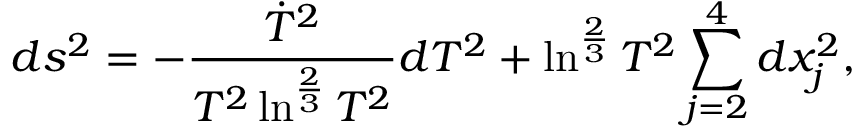Convert formula to latex. <formula><loc_0><loc_0><loc_500><loc_500>d s ^ { 2 } = - \frac { \dot { T } ^ { 2 } } { T ^ { 2 } \ln ^ { \frac { 2 } { 3 } } T ^ { 2 } } d T ^ { 2 } + \ln ^ { \frac { 2 } { 3 } } T ^ { 2 } \sum _ { j = 2 } ^ { 4 } d x _ { j } ^ { 2 } ,</formula> 